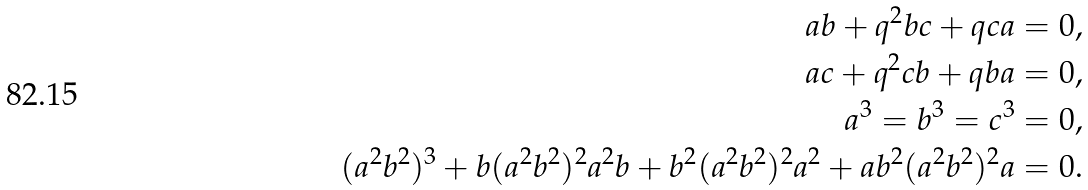Convert formula to latex. <formula><loc_0><loc_0><loc_500><loc_500>a b + q ^ { 2 } b c + q c a = 0 , \\ a c + q ^ { 2 } c b + q b a = 0 , \\ a ^ { 3 } = b ^ { 3 } = c ^ { 3 } = 0 , \\ ( a ^ { 2 } b ^ { 2 } ) ^ { 3 } + b ( a ^ { 2 } b ^ { 2 } ) ^ { 2 } a ^ { 2 } b + b ^ { 2 } ( a ^ { 2 } b ^ { 2 } ) ^ { 2 } a ^ { 2 } + a b ^ { 2 } ( a ^ { 2 } b ^ { 2 } ) ^ { 2 } a = 0 .</formula> 